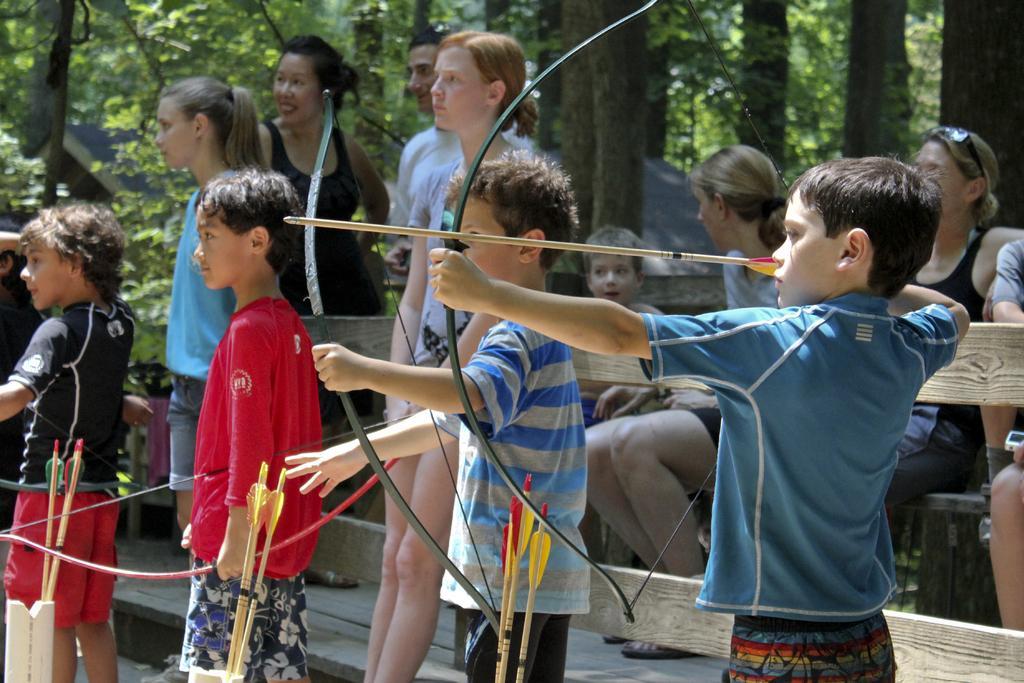How would you summarize this image in a sentence or two? In this image we can see some children holding bow and arrow. And beside we can see some people standing and some are sitting. And we can see the wooden fence. And we can see the trees. 